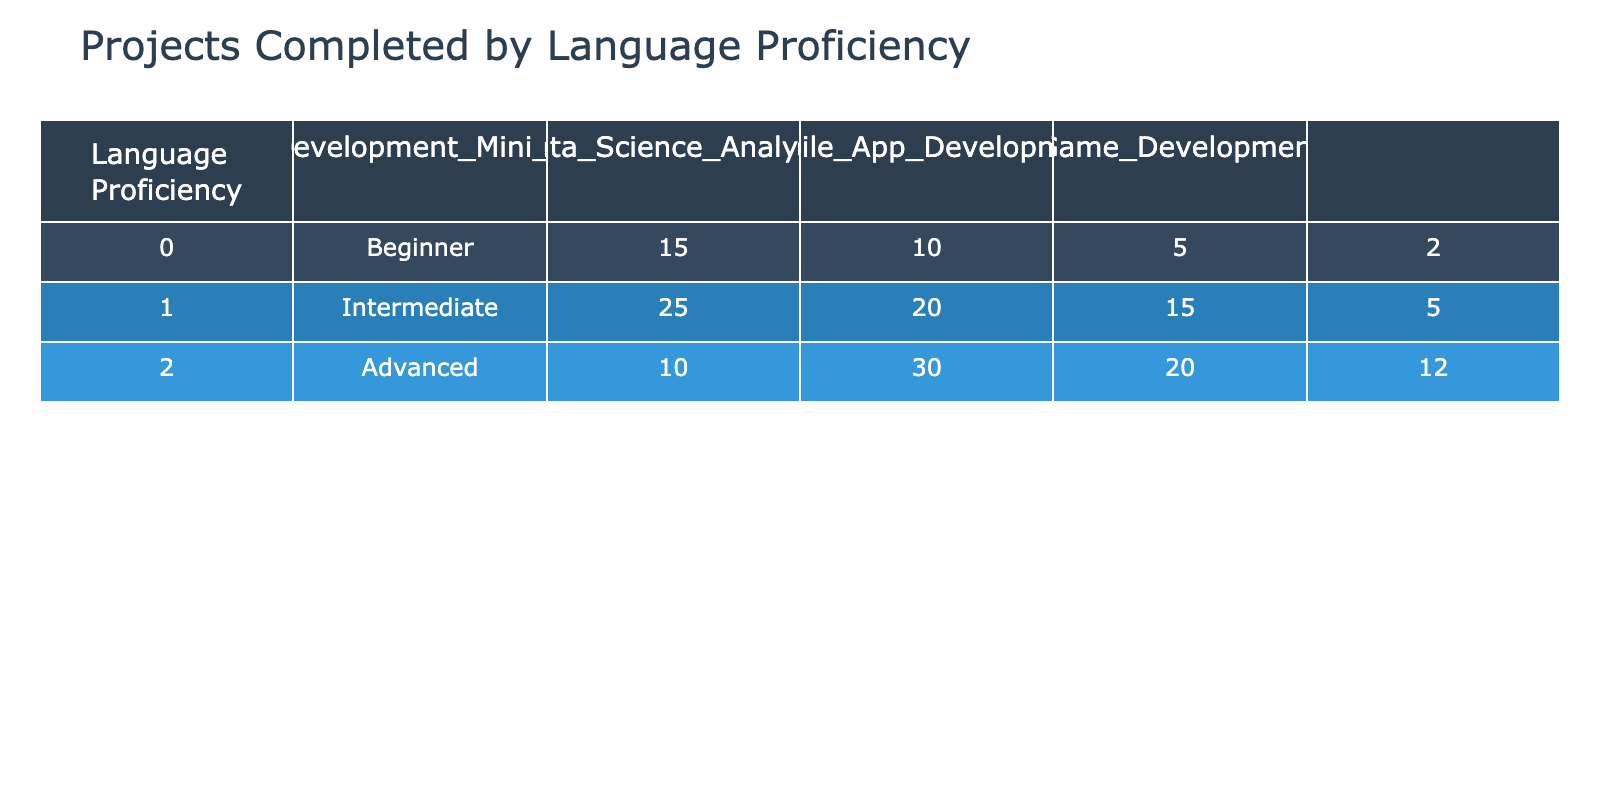What is the total number of students who completed a Web Development Mini Project? The total for Web Development Mini Projects can be calculated by adding the numbers from each proficiency level: 15 (Beginner) + 25 (Intermediate) + 10 (Advanced) = 50.
Answer: 50 What language proficiency level completed the highest number of Data Science Analysis projects? By inspecting the Data Science Analysis column, the counts are: Beginner - 10, Intermediate - 20, and Advanced - 30. Advanced has the highest count at 30.
Answer: Advanced Is it true that the number of Mobile App Development projects completed by Intermediate students is greater than those completed by Advanced students? Looking at the Mobile App Development column, Intermediate students completed 15 projects while Advanced students completed 20 projects. Since 15 is not greater than 20, the statement is false.
Answer: No What is the average number of Game Development projects completed across all language proficiency levels? The total for Game Development can be calculated by summing the counts: 2 (Beginner) + 5 (Intermediate) + 12 (Advanced) = 19. There are three proficiency levels, so the average is 19 divided by 3, which is approximately 6.33.
Answer: Approximately 6.33 Which proficiency level has the lowest completion for Mobile App Development projects? In the Mobile App Development column, the numbers are: 5 (Beginner), 15 (Intermediate), and 20 (Advanced). The lowest is 5 from the Beginner proficiency level.
Answer: Beginner How many more students completed Data Science Analysis than Game Development across all levels combined? The total for Data Science Analysis is 10 (Beginner) + 20 (Intermediate) + 30 (Advanced) = 60. The total for Game Development is 2 (Beginner) + 5 (Intermediate) + 12 (Advanced) = 19. The difference is 60 - 19 = 41.
Answer: 41 What percentage of Advanced students completed Web Development Mini Projects? There are 10 Advanced students who completed Web Development Mini Projects. Total projects completed by Advanced students is 10 (Web) + 30 (Data Science) + 20 (Mobile) + 12 (Game) = 72. The percentage is (10 / 72) * 100, which is approximately 13.89%.
Answer: Approximately 13.89% Which type of project has the least total completions when all proficiency levels are combined? Summing the projects gives: Web Development - 50, Data Science - 60, Mobile - 40, Game - 19. The least is Game Development with a total of 19 projects.
Answer: Game Development What is the total number of projects completed by Intermediate students? The projects completed by Intermediate students are: 25 (Web) + 20 (Data Science) + 15 (Mobile) + 5 (Game) = 65.
Answer: 65 